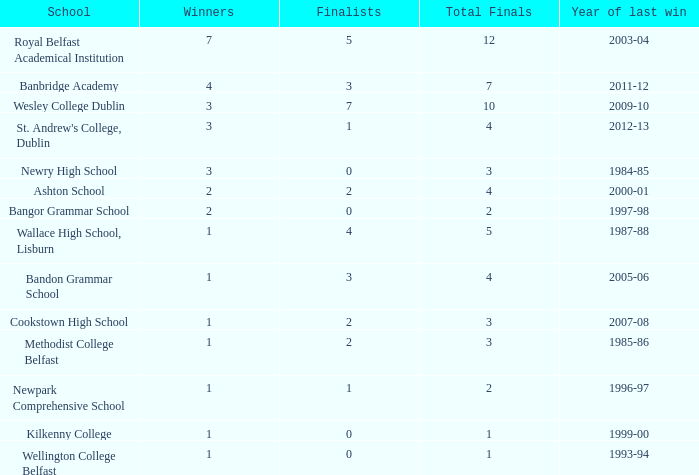What are the names that had a finalist score of 2? Ashton School, Cookstown High School, Methodist College Belfast. 